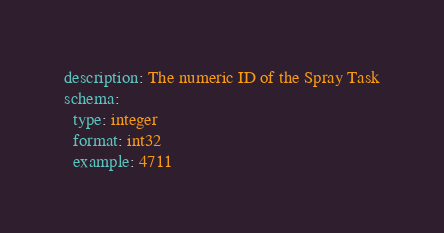<code> <loc_0><loc_0><loc_500><loc_500><_YAML_>description: The numeric ID of the Spray Task
schema:
  type: integer
  format: int32
  example: 4711
</code> 